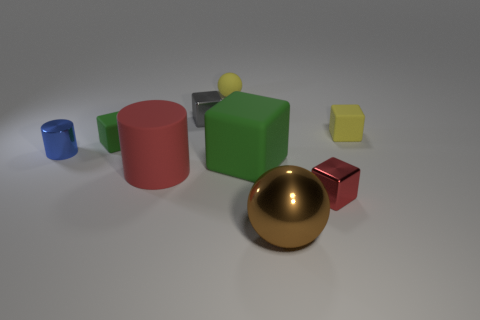Subtract all small gray cubes. How many cubes are left? 4 Subtract all red cubes. How many cubes are left? 4 Subtract all purple cubes. Subtract all red spheres. How many cubes are left? 5 Add 1 big cyan blocks. How many objects exist? 10 Subtract all spheres. How many objects are left? 7 Subtract 0 red spheres. How many objects are left? 9 Subtract all small red objects. Subtract all brown metal objects. How many objects are left? 7 Add 8 brown balls. How many brown balls are left? 9 Add 1 large brown objects. How many large brown objects exist? 2 